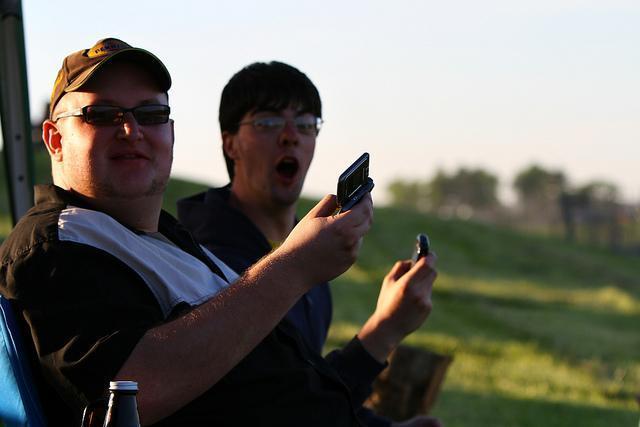How many people are there?
Give a very brief answer. 2. 